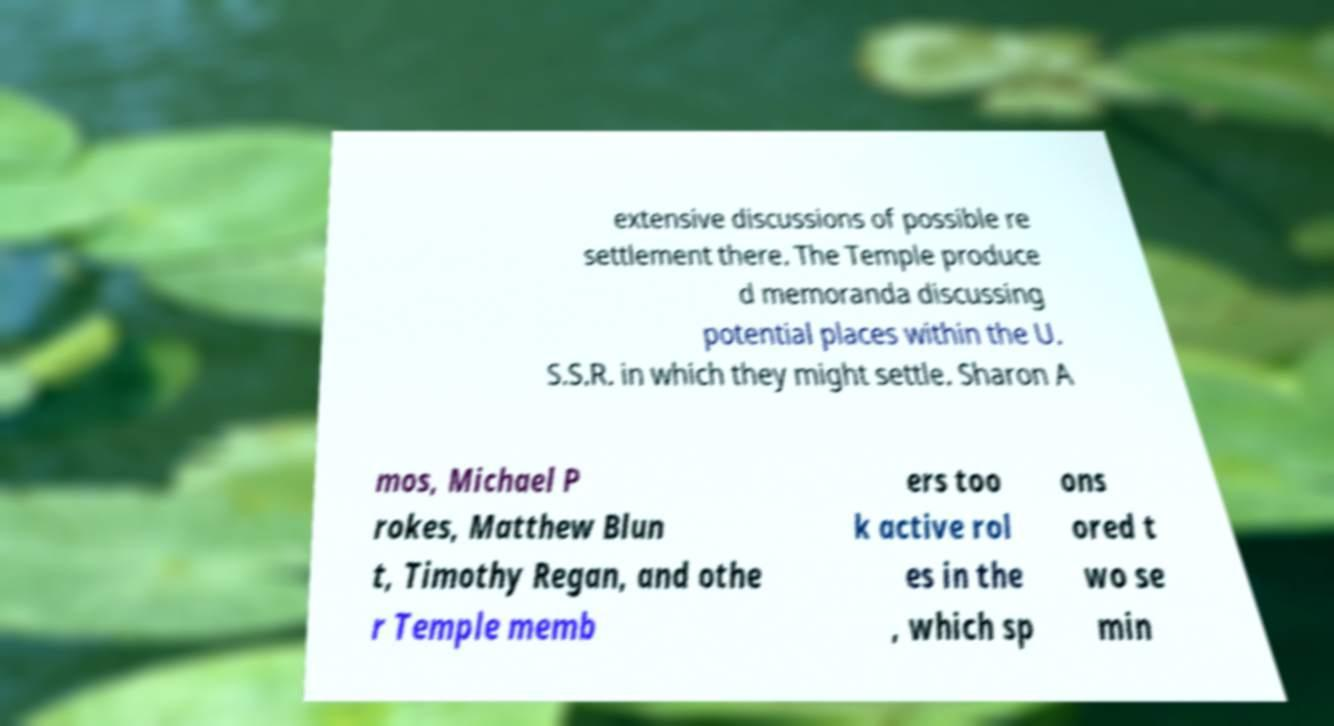There's text embedded in this image that I need extracted. Can you transcribe it verbatim? extensive discussions of possible re settlement there. The Temple produce d memoranda discussing potential places within the U. S.S.R. in which they might settle. Sharon A mos, Michael P rokes, Matthew Blun t, Timothy Regan, and othe r Temple memb ers too k active rol es in the , which sp ons ored t wo se min 